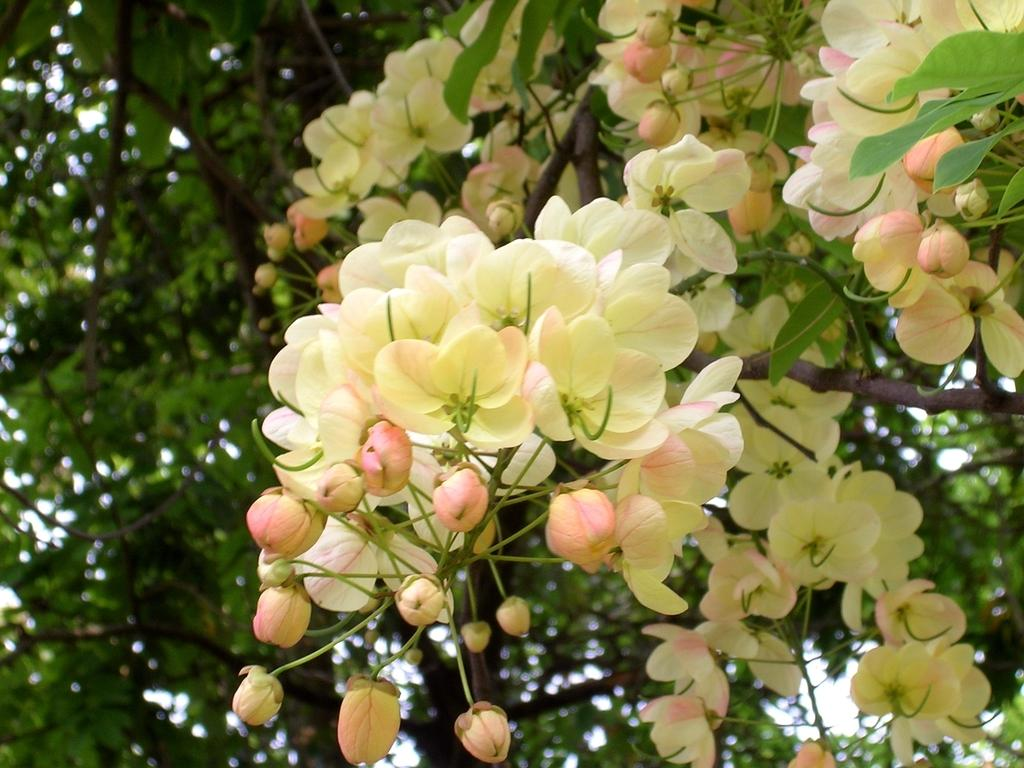What type of plant life is visible in the image? There are flowers, buds, branches, and leaves visible in the image. Can you describe the different stages of growth depicted in the image? The image shows both buds and flowers, indicating different stages of growth. What parts of the plant are visible in the image? The image shows branches and leaves in addition to the flowers and buds. How does the dog interact with the flowers in the image? There is no dog present in the image; it only features plant life. 